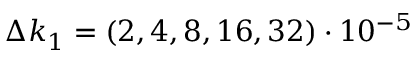Convert formula to latex. <formula><loc_0><loc_0><loc_500><loc_500>\Delta k _ { 1 } = ( 2 , 4 , 8 , 1 6 , 3 2 ) \cdot 1 0 ^ { - 5 }</formula> 